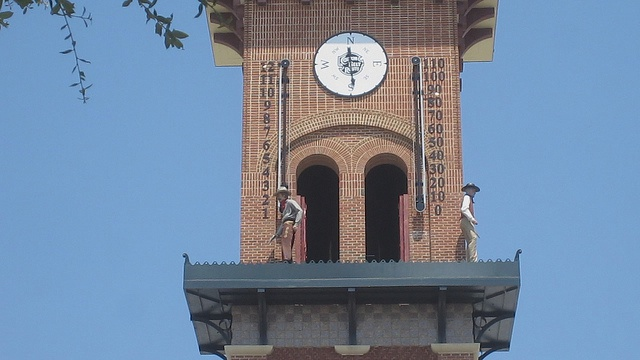Describe the objects in this image and their specific colors. I can see clock in black, lightgray, gray, darkgray, and lightblue tones, people in black, gray, and darkgray tones, and people in black, gray, darkgray, and lightgray tones in this image. 